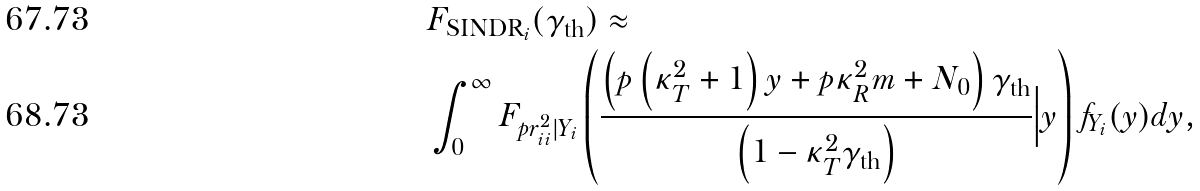<formula> <loc_0><loc_0><loc_500><loc_500>& F _ { \text {SINDR} _ { i } } ( \gamma _ { \text {th} } ) \approx \\ & \int ^ { \infty } _ { 0 } F _ { p r ^ { 2 } _ { i i } | Y _ { i } } \left ( \frac { \left ( p \left ( \kappa ^ { 2 } _ { T } + 1 \right ) y + p \kappa ^ { 2 } _ { R } m + N _ { 0 } \right ) \gamma _ { \text {th} } } { \left ( 1 - \kappa ^ { 2 } _ { T } \gamma _ { \text {th} } \right ) } \Big | y \right ) f _ { Y _ { i } } ( y ) d y ,</formula> 